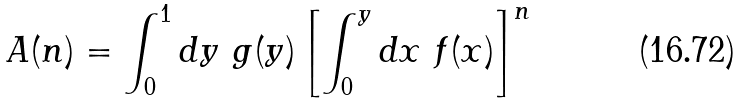Convert formula to latex. <formula><loc_0><loc_0><loc_500><loc_500>A ( n ) = \int _ { 0 } ^ { 1 } d y { \ } g ( y ) \left [ \int ^ { y } _ { 0 } d x { \ } f ( x ) \right ] ^ { n }</formula> 